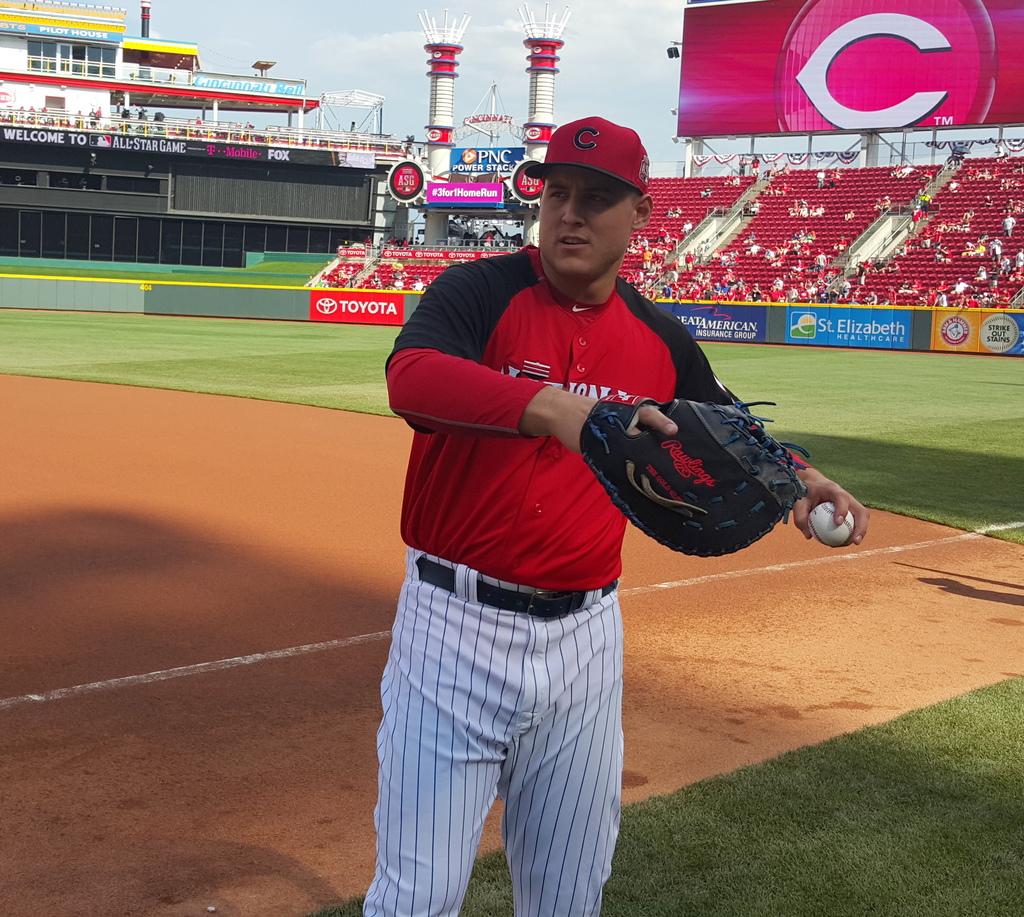What is one of the brands advertised on the stands?
Provide a succinct answer. Toyota. A welcome to what company?
Make the answer very short. All star game. 